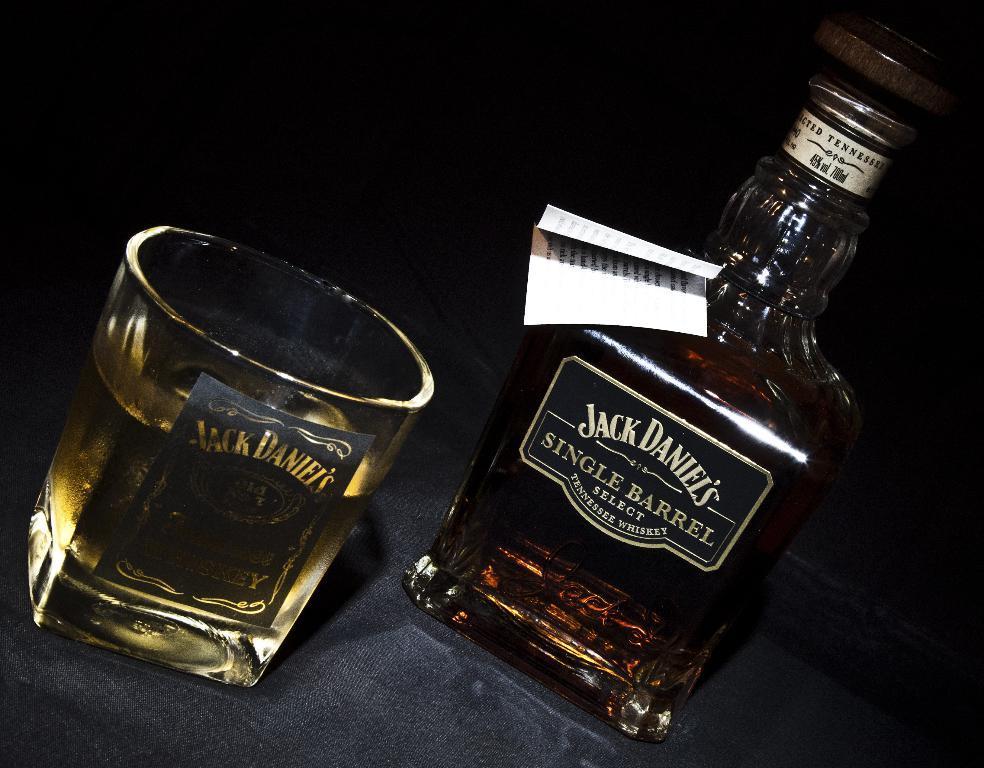Describe this image in one or two sentences. In this picture we can see bottle attached with paper and glass with drink. 